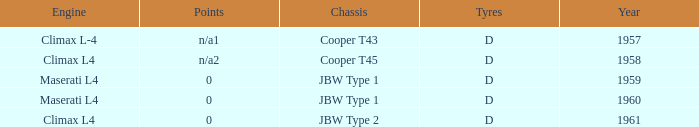What is the tyres for the JBW type 2 chassis? D. 